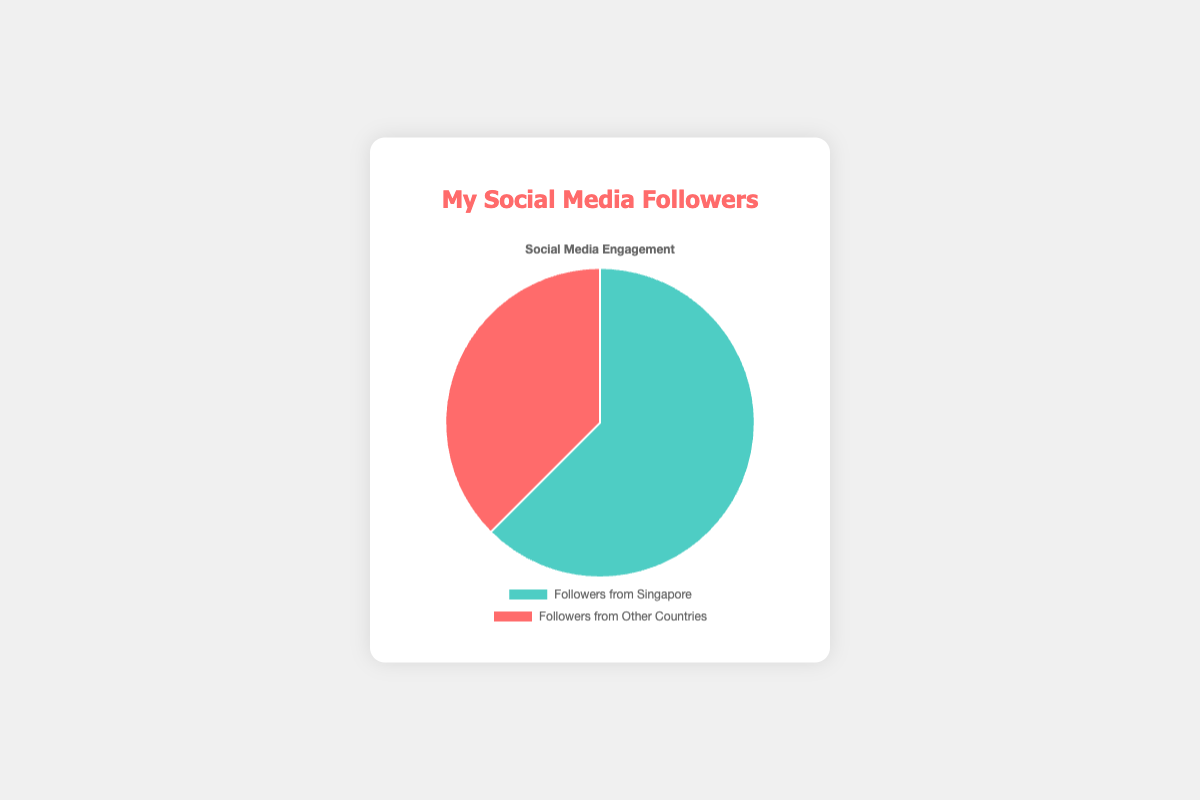What are the respective percentages of followers from Singapore and from other countries? To find the percentages, we first calculate the total number of followers (1250 + 750 = 2000). The percentage for followers from Singapore is (1250 / 2000) * 100 = 62.5%. The percentage for followers from other countries is (750 / 2000) * 100 = 37.5%.
Answer: Followers from Singapore: 62.5%, Followers from Other Countries: 37.5% Which category has more followers, and by how many? To determine which category has more followers, we compare the counts. Followers from Singapore (1250) is greater than followers from other countries (750). The difference is 1250 - 750 = 500.
Answer: Followers from Singapore by 500 What is the ratio of followers from Singapore to followers from other countries? The ratio is calculated by dividing the count of followers from Singapore by the count of followers from other countries. So, the ratio is 1250 / 750 = 5 / 3 or approximately 1.67.
Answer: 5:3 (or 1.67) If you gain 250 more followers from other countries, what would be the new percentage of total followers from other countries? Adding 250 to the current 750 followers from other countries, the new count is 750 + 250 = 1000. The total number of followers would then be 1250 + 1000 = 2250. The percentage of followers from other countries would be (1000 / 2250) * 100 ≈ 44.4%.
Answer: 44.4% How much more area does the slice representing followers from Singapore occupy compared to the slice for other countries? The areas in a pie chart are proportional to the quantities they represent. Since followers from Singapore are 1250 compared to 750 from other countries, the Singapore slice is larger by a factor of 1250 / 750 ≈ 1.67.
Answer: 1.67 times more What is the difference in percentage between followers from Singapore and followers from other countries? The percentage of followers from Singapore is 62.5% and from other countries is 37.5%. The difference is 62.5% - 37.5% = 25%.
Answer: 25% If the colors for the categories are teal for followers from Singapore and red for followers from other countries, which category is represented by a red slice? According to the given color information, the followers from other countries are represented by the red slice.
Answer: Followers from Other Countries If you lose 100 followers from Singapore, what will be the new percentages of followers from Singapore and other countries? Reducing the Singapore followers to 1250 - 100 = 1150, the total followers will be 1150 + 750 = 1900. The new percentage for Singapore is (1150 / 1900) * 100 ≈ 60.5%, and for other countries, it remains (750 / 1900) * 100 ≈ 39.5%.
Answer: Followers from Singapore: 60.5%, Followers from Other Countries: 39.5% If another artist in Singapore has the reverse follower distribution, how many followers do they have in total? If they have 750 followers from Singapore and 1250 from other countries, their total is 750 + 1250 = 2000 followers.
Answer: 2000 